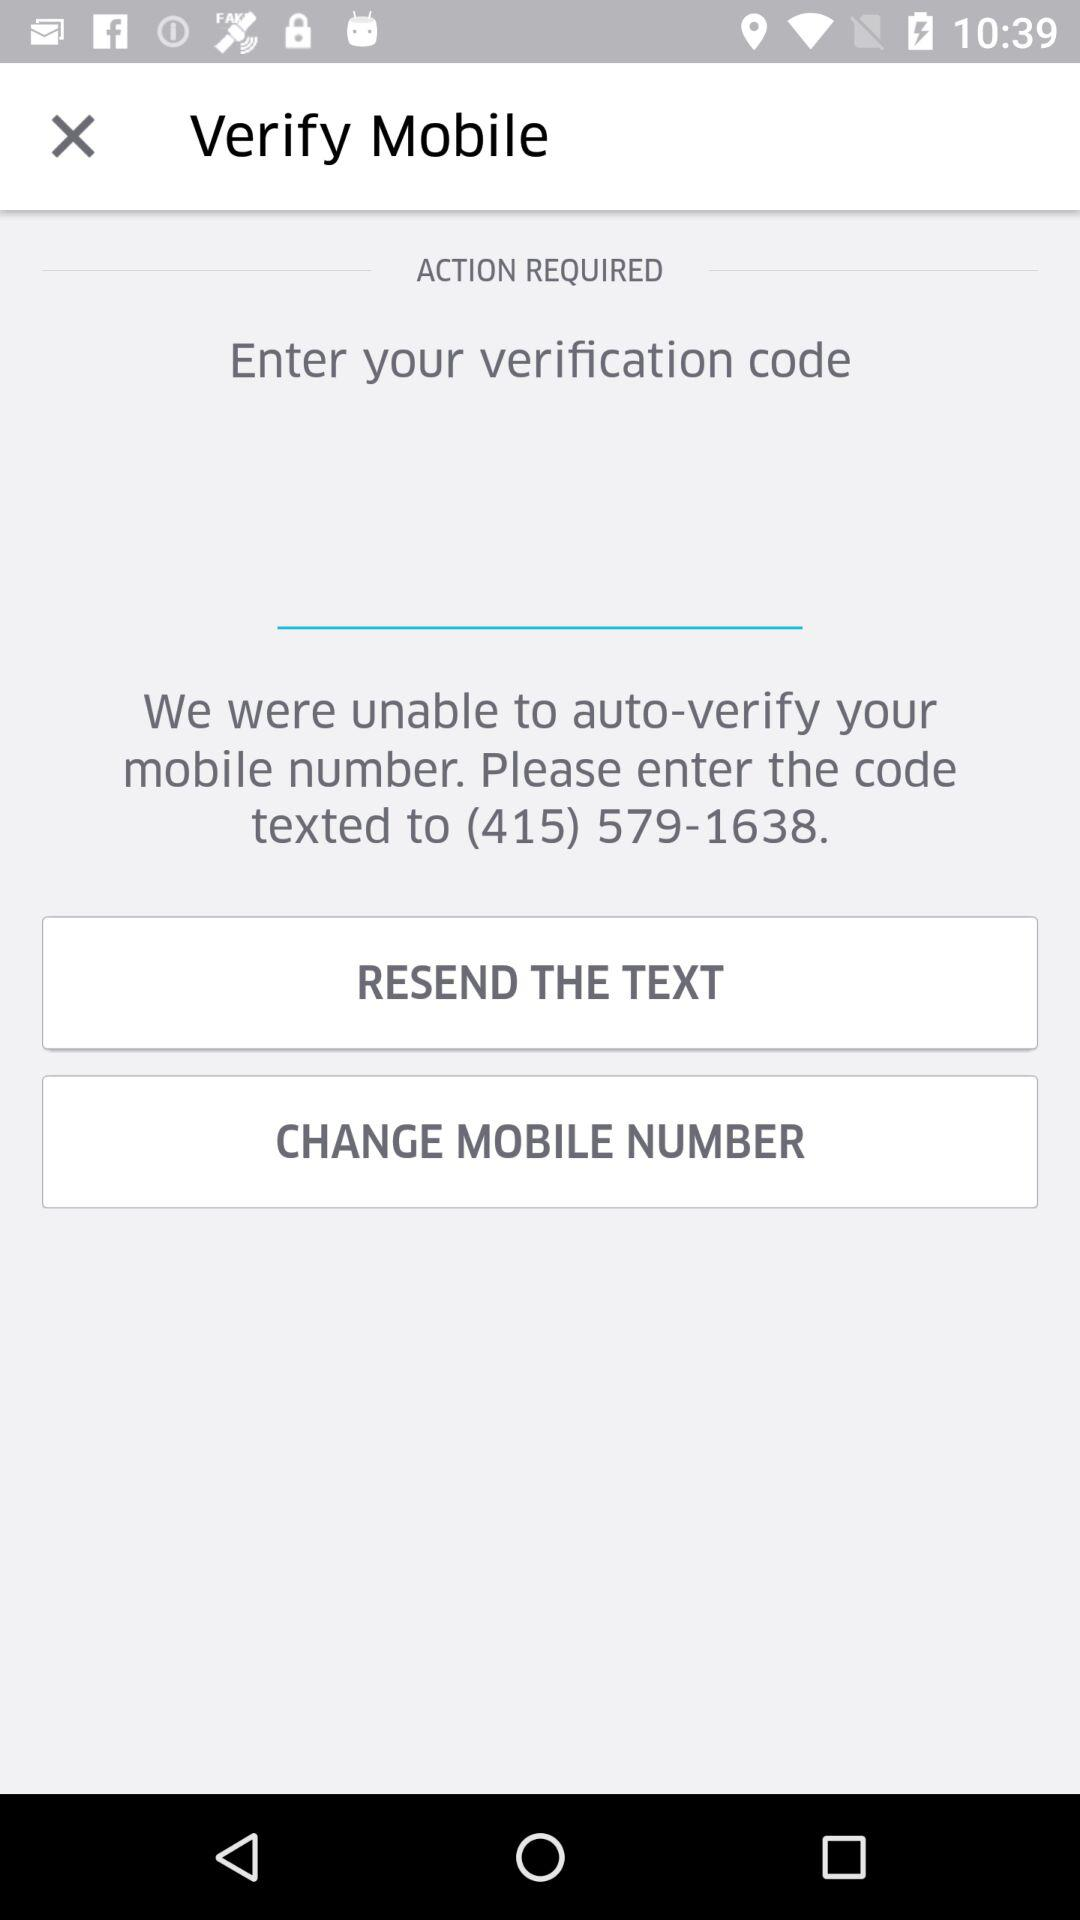What is the mobile number to which the verification code has been sent? The mobile number to which the verification code has been sent is (415) 579-1638. 